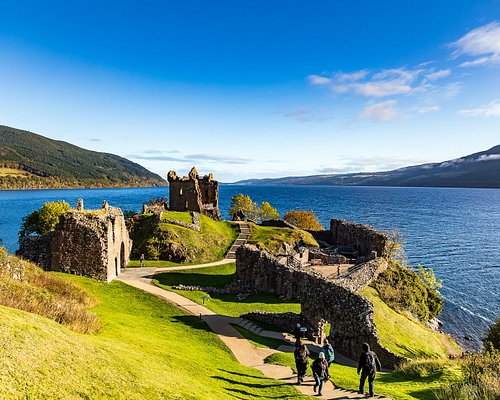Imagine if the castle were to be rebuilt in modern times. What might it look like? If Urquhart Castle were to be rebuilt in modern times, it might blend historical architecture with contemporary design. Envision a structure that retains the rugged stone and defensive features of the medieval castle, yet incorporates modern materials such as glass and steel. This rebuilt castle could feature expansive glass walls offering panoramic views of Loch Ness, sleek, modern interiors that contrast with the ancient stone exteriors, and innovative uses of light and space to create a harmonious blend of the old and new. Advanced technology could be integrated for interactive historical exhibits, making it not just a tourist attraction but a living museum. 